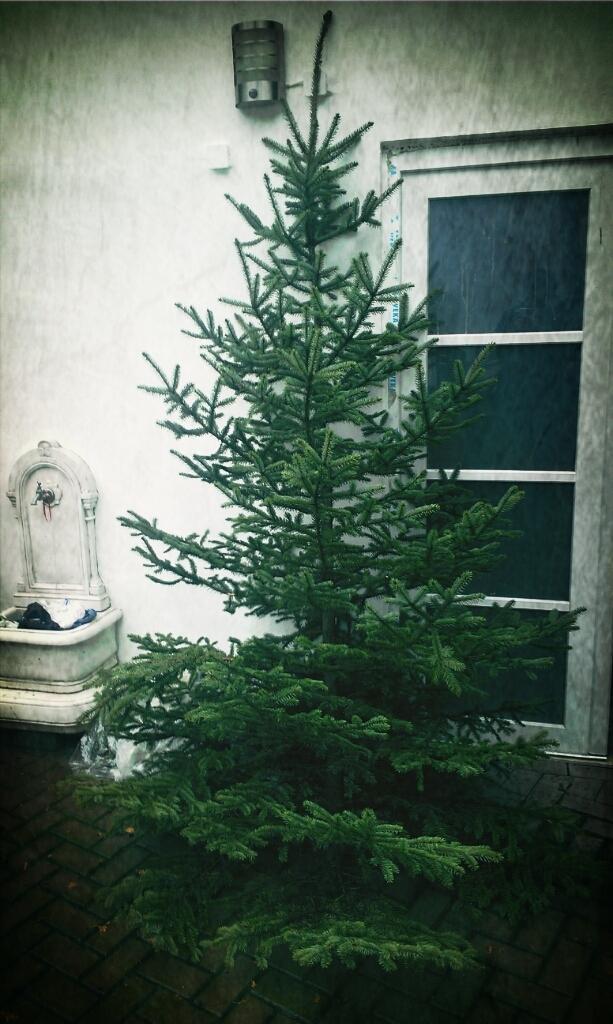Can you describe this image briefly? This image consists of a plant in the middle. There is a window on the right side. 